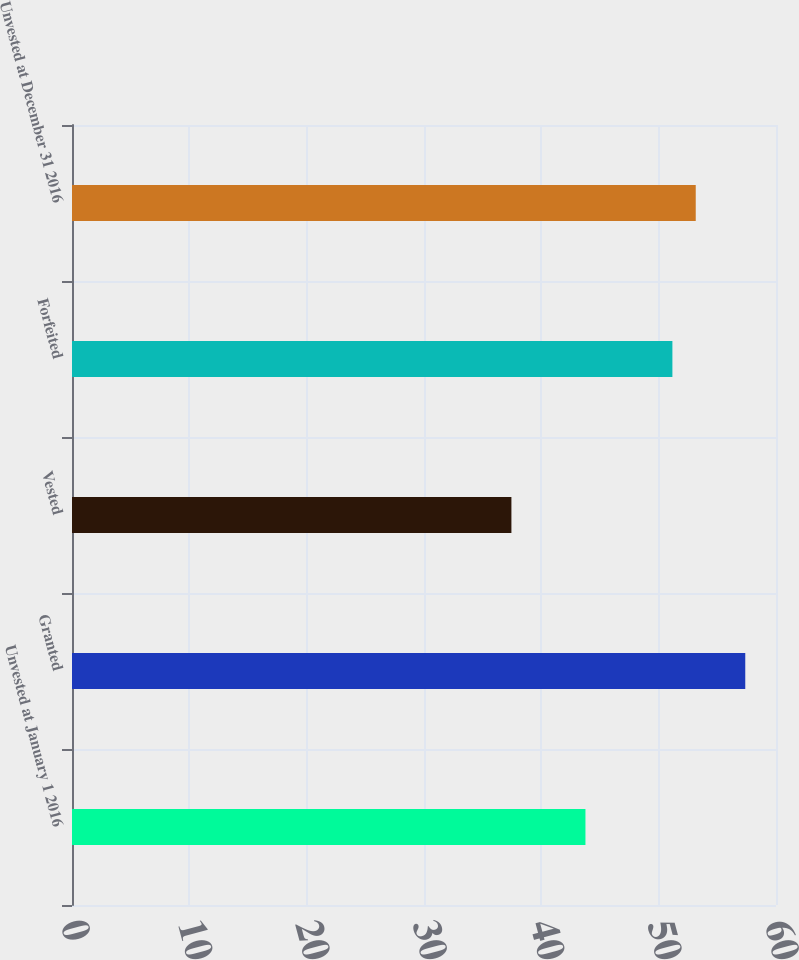Convert chart. <chart><loc_0><loc_0><loc_500><loc_500><bar_chart><fcel>Unvested at January 1 2016<fcel>Granted<fcel>Vested<fcel>Forfeited<fcel>Unvested at December 31 2016<nl><fcel>43.76<fcel>57.38<fcel>37.45<fcel>51.17<fcel>53.16<nl></chart> 